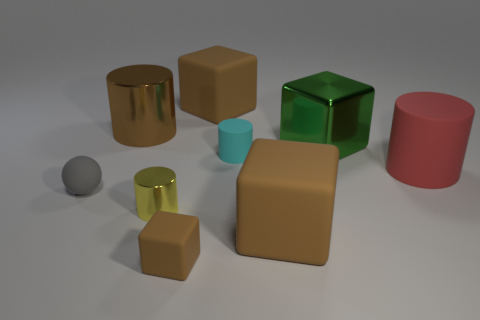Subtract all green cylinders. How many brown cubes are left? 3 Add 1 large metallic cubes. How many objects exist? 10 Subtract all cylinders. How many objects are left? 5 Subtract 0 gray blocks. How many objects are left? 9 Subtract all tiny things. Subtract all big red shiny things. How many objects are left? 5 Add 5 large rubber things. How many large rubber things are left? 8 Add 3 brown cubes. How many brown cubes exist? 6 